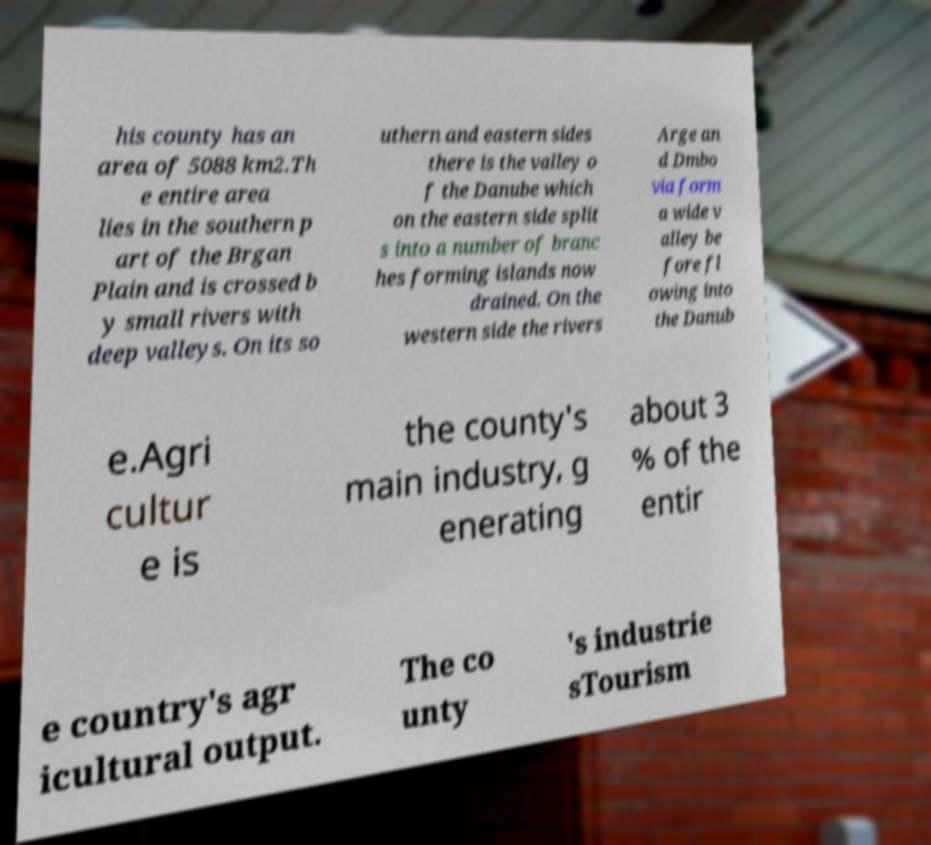For documentation purposes, I need the text within this image transcribed. Could you provide that? his county has an area of 5088 km2.Th e entire area lies in the southern p art of the Brgan Plain and is crossed b y small rivers with deep valleys. On its so uthern and eastern sides there is the valley o f the Danube which on the eastern side split s into a number of branc hes forming islands now drained. On the western side the rivers Arge an d Dmbo via form a wide v alley be fore fl owing into the Danub e.Agri cultur e is the county's main industry, g enerating about 3 % of the entir e country's agr icultural output. The co unty 's industrie sTourism 